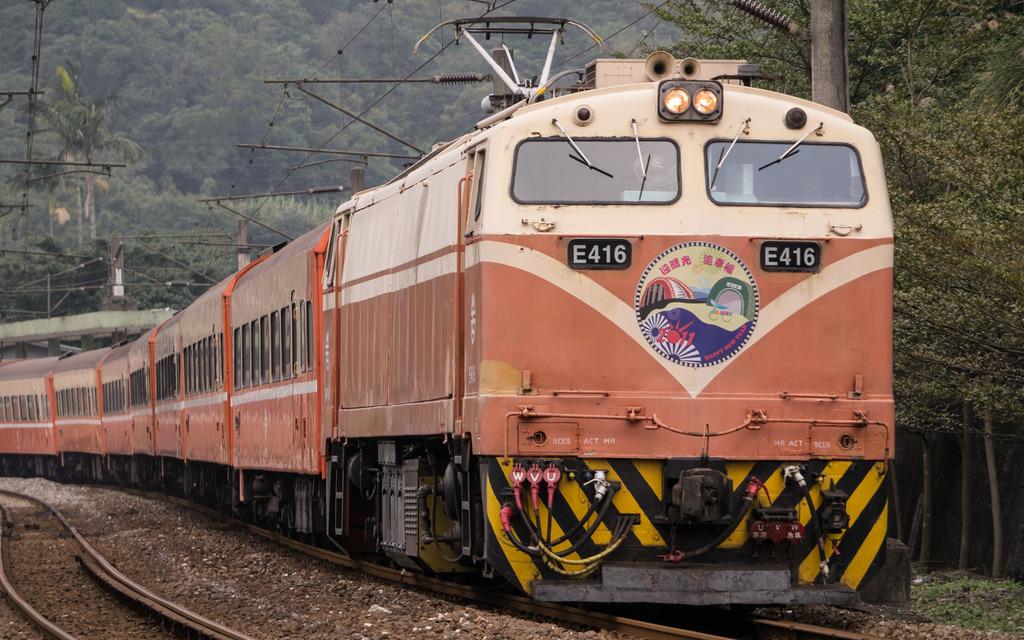What code is on the front of the train?
Your response must be concise. E416. How many headlights are on the front of the train?
Your answer should be compact. Answering does not require reading text in the image. 